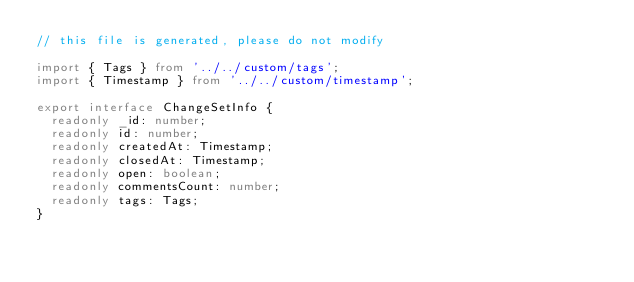Convert code to text. <code><loc_0><loc_0><loc_500><loc_500><_TypeScript_>// this file is generated, please do not modify

import { Tags } from '../../custom/tags';
import { Timestamp } from '../../custom/timestamp';

export interface ChangeSetInfo {
  readonly _id: number;
  readonly id: number;
  readonly createdAt: Timestamp;
  readonly closedAt: Timestamp;
  readonly open: boolean;
  readonly commentsCount: number;
  readonly tags: Tags;
}
</code> 